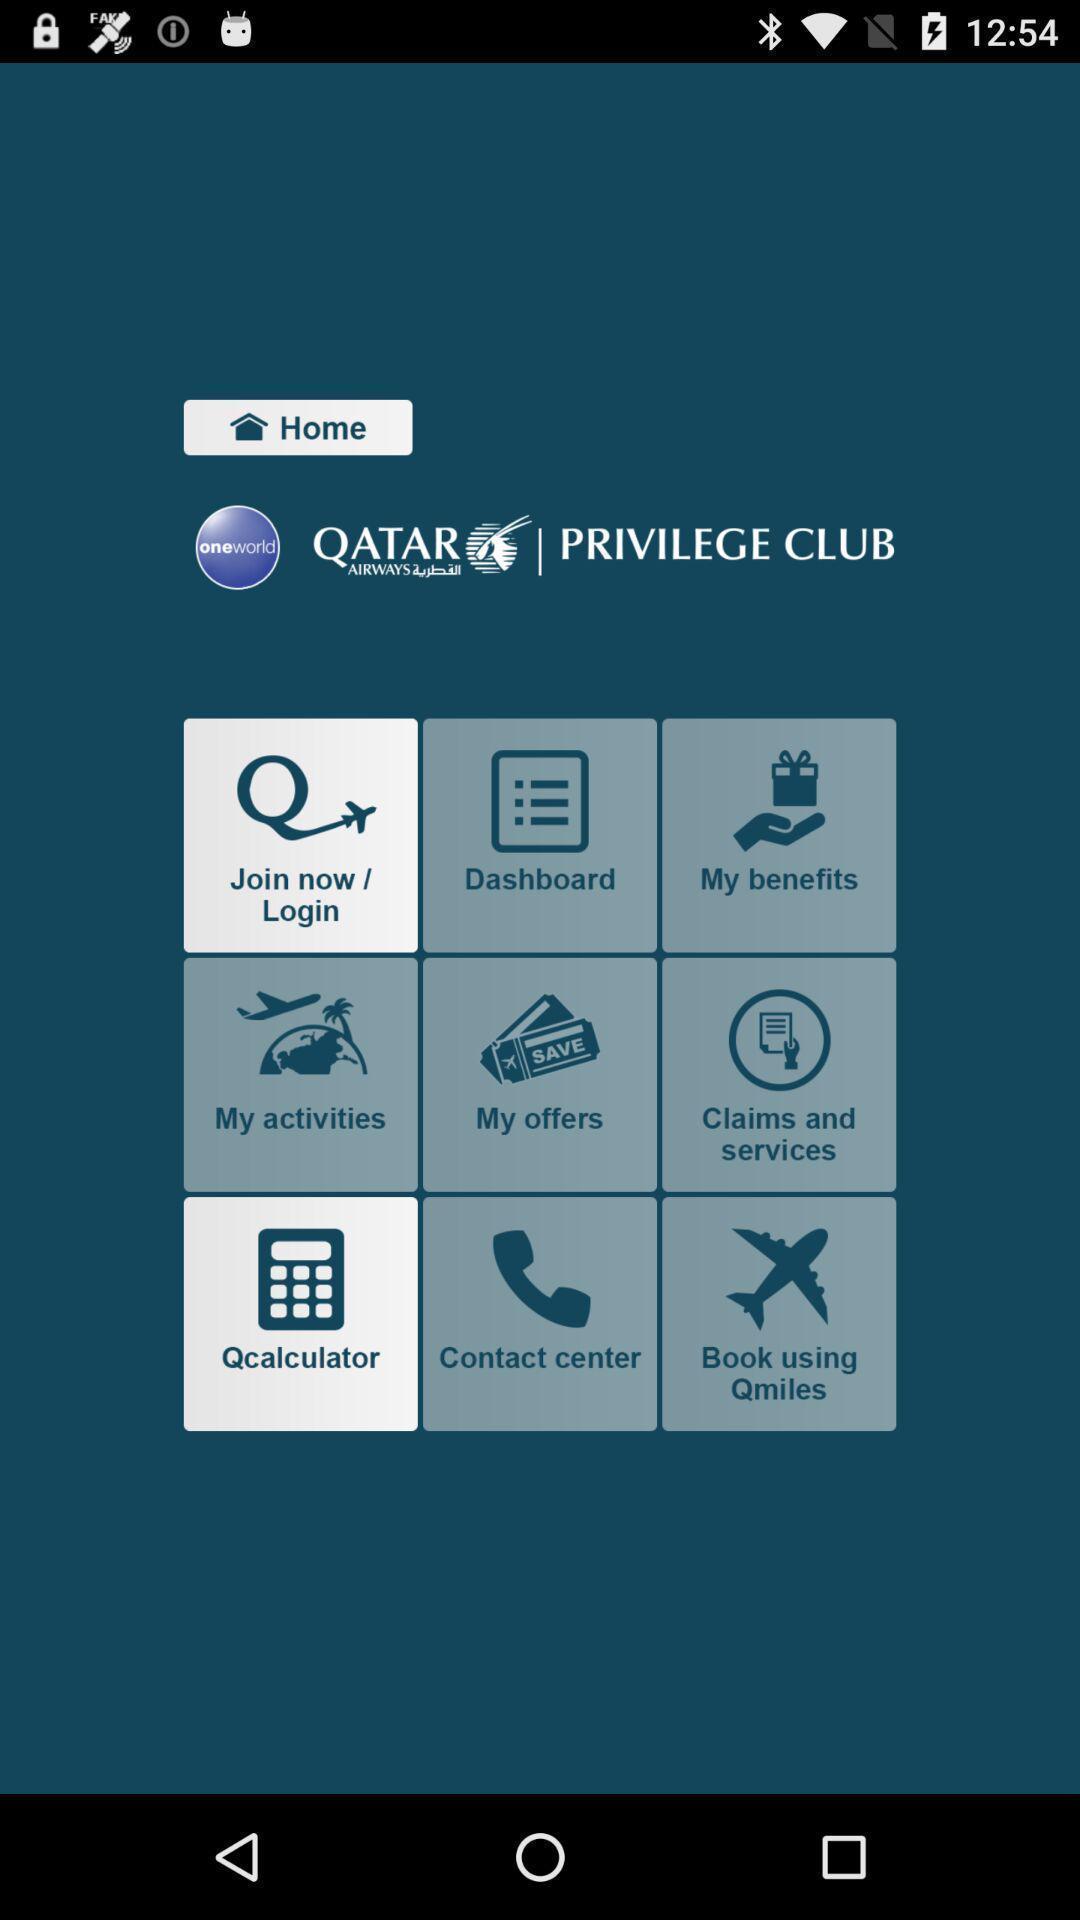Describe the visual elements of this screenshot. Home screen displaying various options for travel app. 